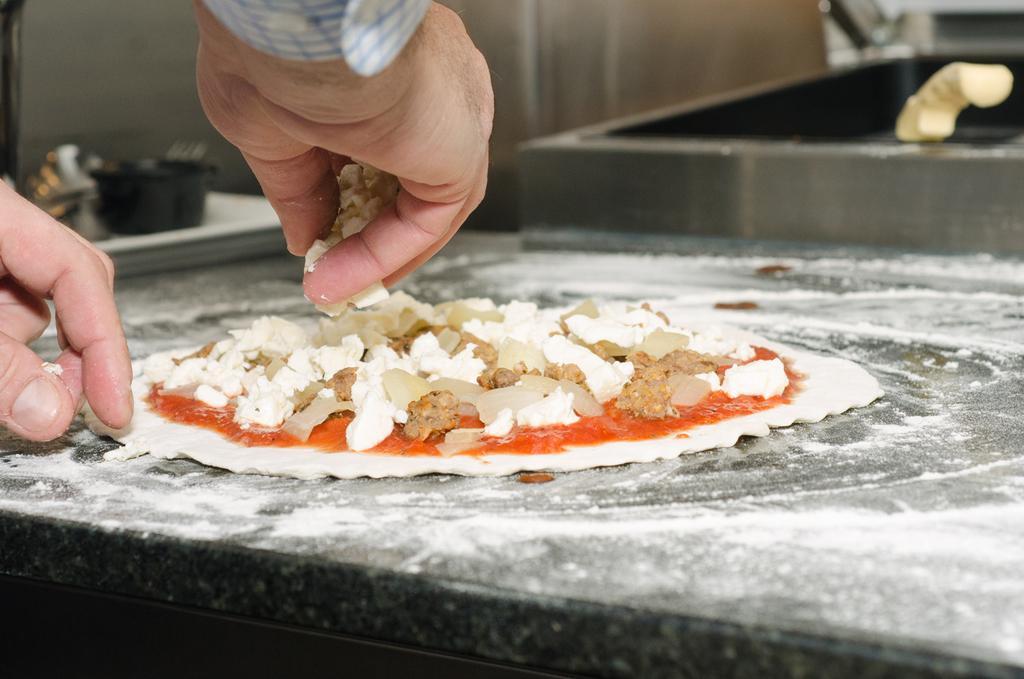In one or two sentences, can you explain what this image depicts? In this image there is a table on which there is a pizza. On the left side there is a person who is keeping some food stuff on the pizza. On the right side top there is a sink. On the left side there are bowls and spoons. 